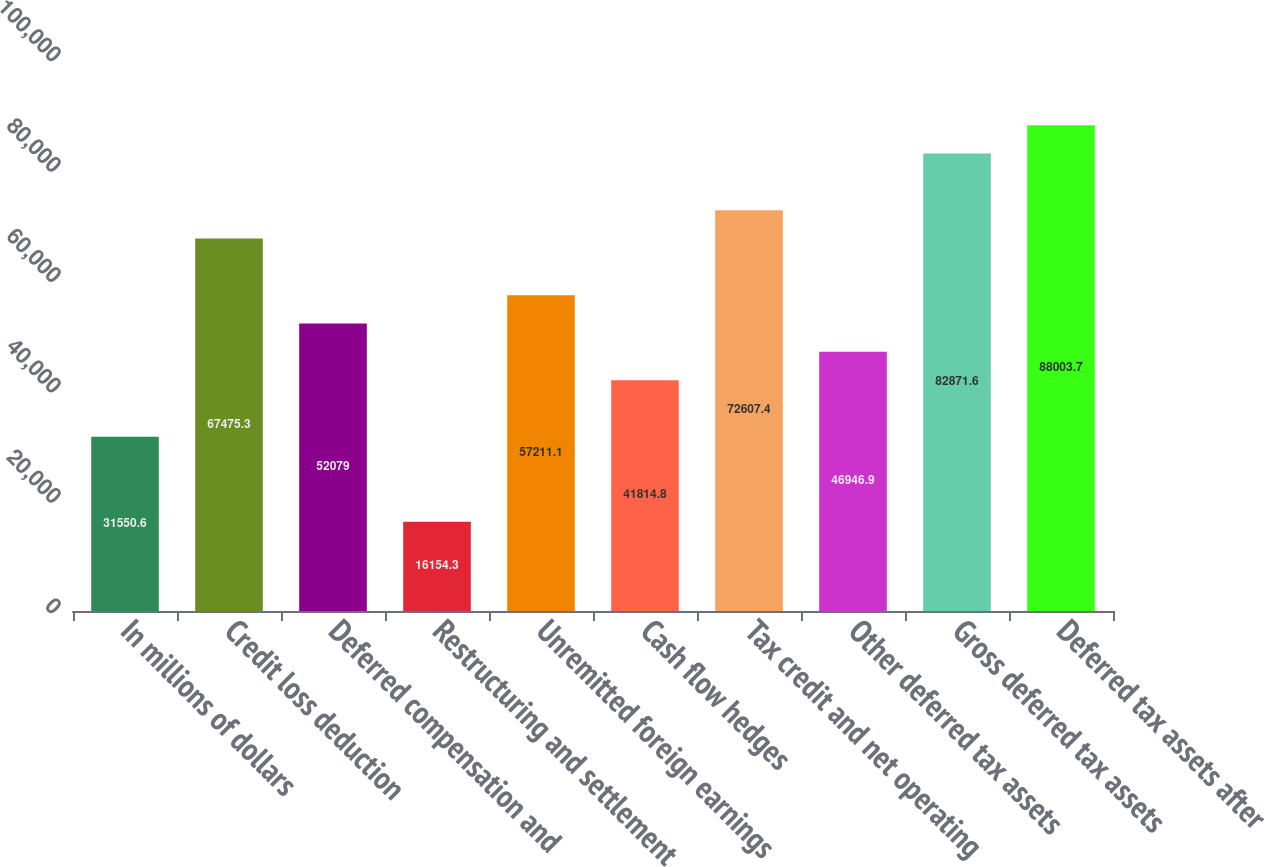<chart> <loc_0><loc_0><loc_500><loc_500><bar_chart><fcel>In millions of dollars<fcel>Credit loss deduction<fcel>Deferred compensation and<fcel>Restructuring and settlement<fcel>Unremitted foreign earnings<fcel>Cash flow hedges<fcel>Tax credit and net operating<fcel>Other deferred tax assets<fcel>Gross deferred tax assets<fcel>Deferred tax assets after<nl><fcel>31550.6<fcel>67475.3<fcel>52079<fcel>16154.3<fcel>57211.1<fcel>41814.8<fcel>72607.4<fcel>46946.9<fcel>82871.6<fcel>88003.7<nl></chart> 